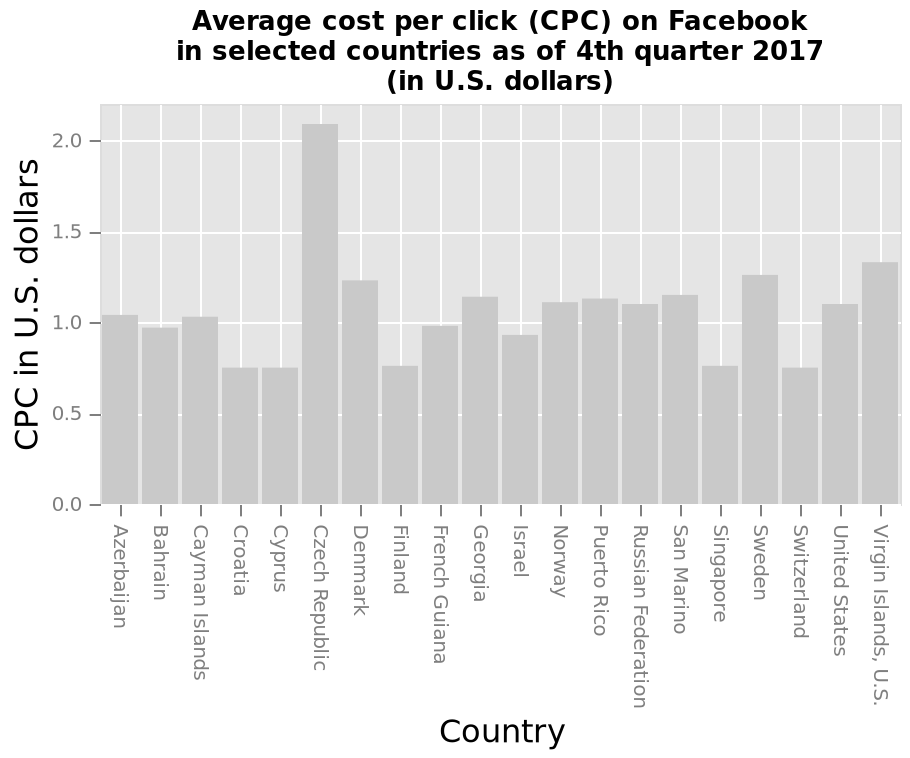<image>
Offer a thorough analysis of the image. The cost varies from $0.70 to over $2.00.  The cost per click in the Czech Republic is over $2.00 - a lot more than any of the other countries shown, with the next highest being the Virgin Islands,US  at around $1.30.  Most of the countries showed a cost of between 0.90 and 1.30.  Under 0.90 were Croatia, Cyprus, Finland, SIngapore and Switzerland. Which country is located at one end of the x-axis?  Azerbaijan is located at one end of the x-axis. please enumerates aspects of the construction of the chart This is a bar plot titled Average cost per click (CPC) on Facebook in selected countries as of 4th quarter 2017 (in U.S. dollars). The y-axis plots CPC in U.S. dollars with linear scale of range 0.0 to 2.0 while the x-axis shows Country with categorical scale with Azerbaijan on one end and Virgin Islands, U.S. at the other. 